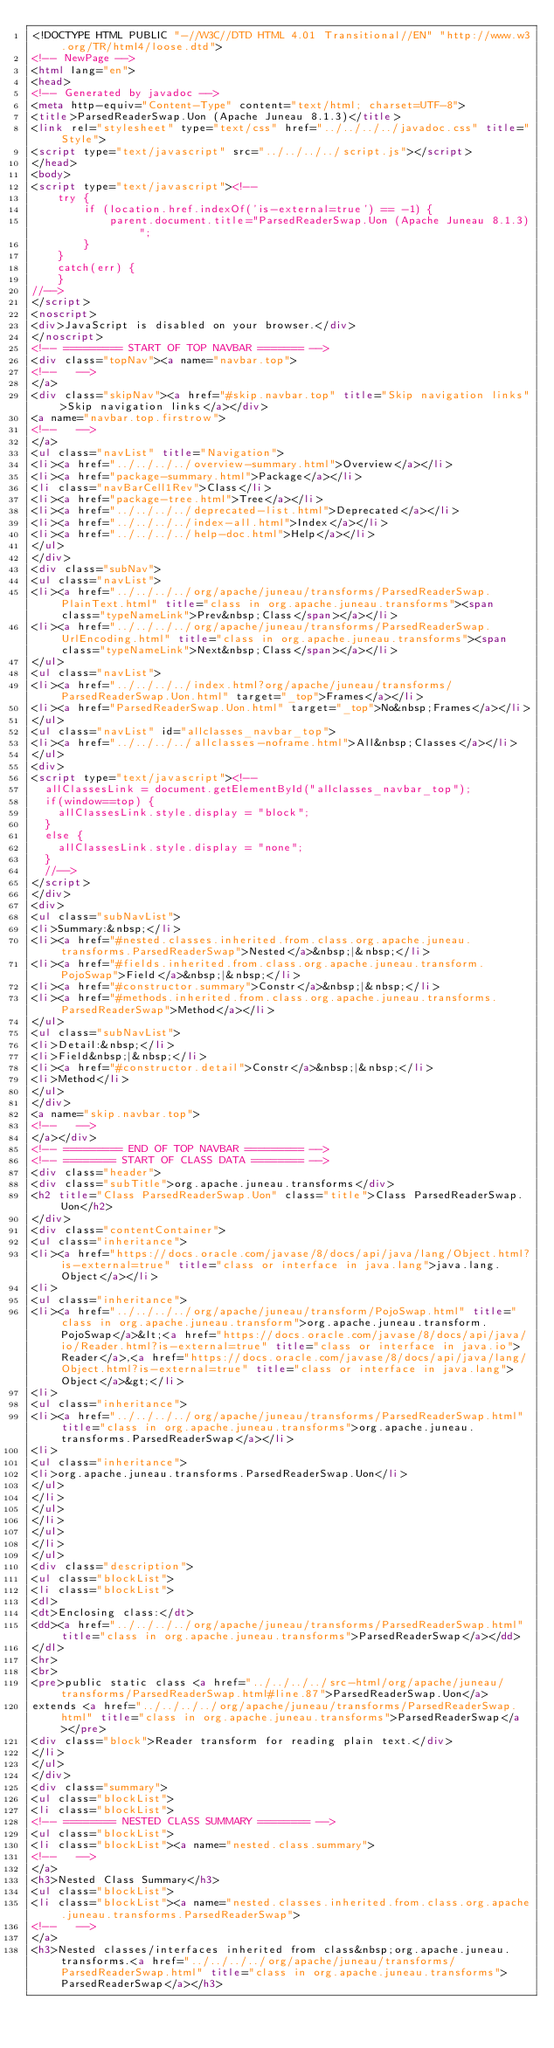<code> <loc_0><loc_0><loc_500><loc_500><_HTML_><!DOCTYPE HTML PUBLIC "-//W3C//DTD HTML 4.01 Transitional//EN" "http://www.w3.org/TR/html4/loose.dtd">
<!-- NewPage -->
<html lang="en">
<head>
<!-- Generated by javadoc -->
<meta http-equiv="Content-Type" content="text/html; charset=UTF-8">
<title>ParsedReaderSwap.Uon (Apache Juneau 8.1.3)</title>
<link rel="stylesheet" type="text/css" href="../../../../javadoc.css" title="Style">
<script type="text/javascript" src="../../../../script.js"></script>
</head>
<body>
<script type="text/javascript"><!--
    try {
        if (location.href.indexOf('is-external=true') == -1) {
            parent.document.title="ParsedReaderSwap.Uon (Apache Juneau 8.1.3)";
        }
    }
    catch(err) {
    }
//-->
</script>
<noscript>
<div>JavaScript is disabled on your browser.</div>
</noscript>
<!-- ========= START OF TOP NAVBAR ======= -->
<div class="topNav"><a name="navbar.top">
<!--   -->
</a>
<div class="skipNav"><a href="#skip.navbar.top" title="Skip navigation links">Skip navigation links</a></div>
<a name="navbar.top.firstrow">
<!--   -->
</a>
<ul class="navList" title="Navigation">
<li><a href="../../../../overview-summary.html">Overview</a></li>
<li><a href="package-summary.html">Package</a></li>
<li class="navBarCell1Rev">Class</li>
<li><a href="package-tree.html">Tree</a></li>
<li><a href="../../../../deprecated-list.html">Deprecated</a></li>
<li><a href="../../../../index-all.html">Index</a></li>
<li><a href="../../../../help-doc.html">Help</a></li>
</ul>
</div>
<div class="subNav">
<ul class="navList">
<li><a href="../../../../org/apache/juneau/transforms/ParsedReaderSwap.PlainText.html" title="class in org.apache.juneau.transforms"><span class="typeNameLink">Prev&nbsp;Class</span></a></li>
<li><a href="../../../../org/apache/juneau/transforms/ParsedReaderSwap.UrlEncoding.html" title="class in org.apache.juneau.transforms"><span class="typeNameLink">Next&nbsp;Class</span></a></li>
</ul>
<ul class="navList">
<li><a href="../../../../index.html?org/apache/juneau/transforms/ParsedReaderSwap.Uon.html" target="_top">Frames</a></li>
<li><a href="ParsedReaderSwap.Uon.html" target="_top">No&nbsp;Frames</a></li>
</ul>
<ul class="navList" id="allclasses_navbar_top">
<li><a href="../../../../allclasses-noframe.html">All&nbsp;Classes</a></li>
</ul>
<div>
<script type="text/javascript"><!--
  allClassesLink = document.getElementById("allclasses_navbar_top");
  if(window==top) {
    allClassesLink.style.display = "block";
  }
  else {
    allClassesLink.style.display = "none";
  }
  //-->
</script>
</div>
<div>
<ul class="subNavList">
<li>Summary:&nbsp;</li>
<li><a href="#nested.classes.inherited.from.class.org.apache.juneau.transforms.ParsedReaderSwap">Nested</a>&nbsp;|&nbsp;</li>
<li><a href="#fields.inherited.from.class.org.apache.juneau.transform.PojoSwap">Field</a>&nbsp;|&nbsp;</li>
<li><a href="#constructor.summary">Constr</a>&nbsp;|&nbsp;</li>
<li><a href="#methods.inherited.from.class.org.apache.juneau.transforms.ParsedReaderSwap">Method</a></li>
</ul>
<ul class="subNavList">
<li>Detail:&nbsp;</li>
<li>Field&nbsp;|&nbsp;</li>
<li><a href="#constructor.detail">Constr</a>&nbsp;|&nbsp;</li>
<li>Method</li>
</ul>
</div>
<a name="skip.navbar.top">
<!--   -->
</a></div>
<!-- ========= END OF TOP NAVBAR ========= -->
<!-- ======== START OF CLASS DATA ======== -->
<div class="header">
<div class="subTitle">org.apache.juneau.transforms</div>
<h2 title="Class ParsedReaderSwap.Uon" class="title">Class ParsedReaderSwap.Uon</h2>
</div>
<div class="contentContainer">
<ul class="inheritance">
<li><a href="https://docs.oracle.com/javase/8/docs/api/java/lang/Object.html?is-external=true" title="class or interface in java.lang">java.lang.Object</a></li>
<li>
<ul class="inheritance">
<li><a href="../../../../org/apache/juneau/transform/PojoSwap.html" title="class in org.apache.juneau.transform">org.apache.juneau.transform.PojoSwap</a>&lt;<a href="https://docs.oracle.com/javase/8/docs/api/java/io/Reader.html?is-external=true" title="class or interface in java.io">Reader</a>,<a href="https://docs.oracle.com/javase/8/docs/api/java/lang/Object.html?is-external=true" title="class or interface in java.lang">Object</a>&gt;</li>
<li>
<ul class="inheritance">
<li><a href="../../../../org/apache/juneau/transforms/ParsedReaderSwap.html" title="class in org.apache.juneau.transforms">org.apache.juneau.transforms.ParsedReaderSwap</a></li>
<li>
<ul class="inheritance">
<li>org.apache.juneau.transforms.ParsedReaderSwap.Uon</li>
</ul>
</li>
</ul>
</li>
</ul>
</li>
</ul>
<div class="description">
<ul class="blockList">
<li class="blockList">
<dl>
<dt>Enclosing class:</dt>
<dd><a href="../../../../org/apache/juneau/transforms/ParsedReaderSwap.html" title="class in org.apache.juneau.transforms">ParsedReaderSwap</a></dd>
</dl>
<hr>
<br>
<pre>public static class <a href="../../../../src-html/org/apache/juneau/transforms/ParsedReaderSwap.html#line.87">ParsedReaderSwap.Uon</a>
extends <a href="../../../../org/apache/juneau/transforms/ParsedReaderSwap.html" title="class in org.apache.juneau.transforms">ParsedReaderSwap</a></pre>
<div class="block">Reader transform for reading plain text.</div>
</li>
</ul>
</div>
<div class="summary">
<ul class="blockList">
<li class="blockList">
<!-- ======== NESTED CLASS SUMMARY ======== -->
<ul class="blockList">
<li class="blockList"><a name="nested.class.summary">
<!--   -->
</a>
<h3>Nested Class Summary</h3>
<ul class="blockList">
<li class="blockList"><a name="nested.classes.inherited.from.class.org.apache.juneau.transforms.ParsedReaderSwap">
<!--   -->
</a>
<h3>Nested classes/interfaces inherited from class&nbsp;org.apache.juneau.transforms.<a href="../../../../org/apache/juneau/transforms/ParsedReaderSwap.html" title="class in org.apache.juneau.transforms">ParsedReaderSwap</a></h3></code> 